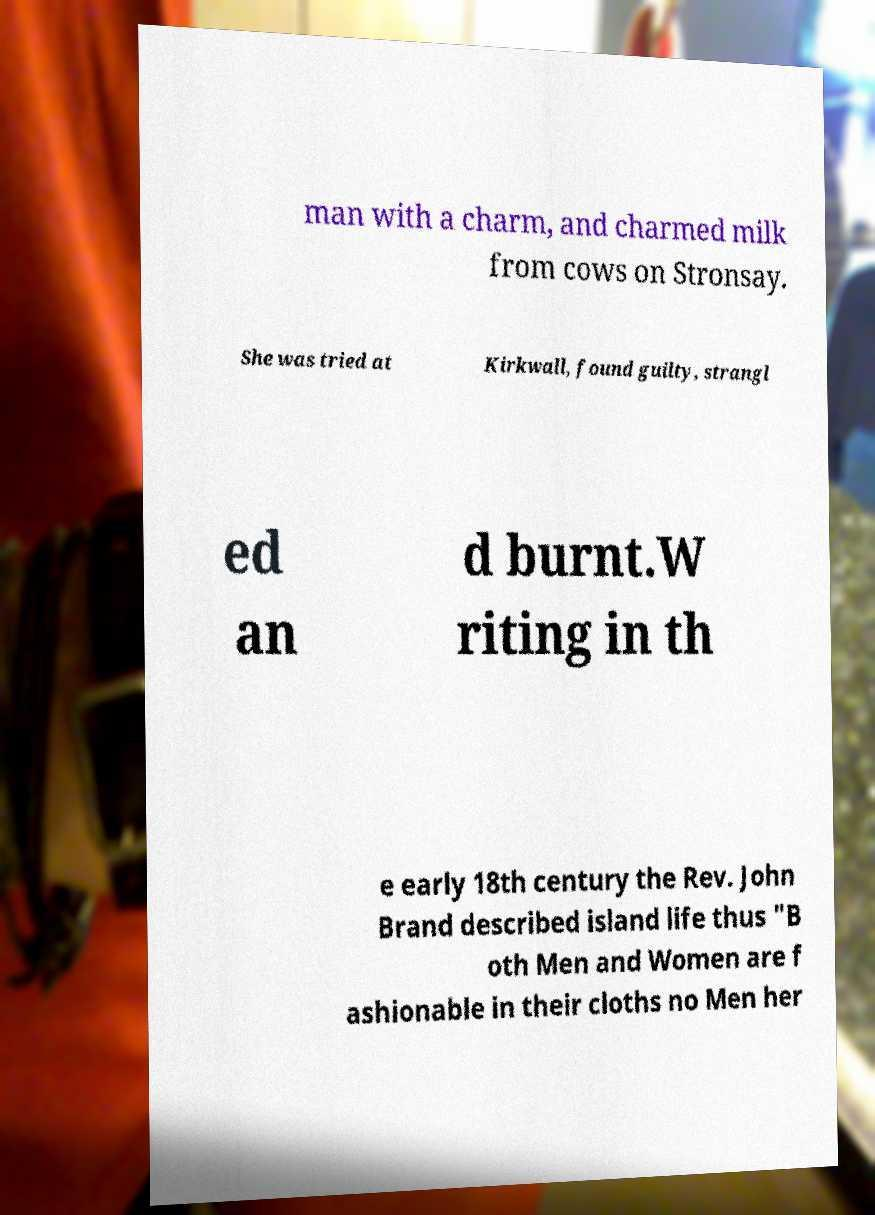Could you assist in decoding the text presented in this image and type it out clearly? man with a charm, and charmed milk from cows on Stronsay. She was tried at Kirkwall, found guilty, strangl ed an d burnt.W riting in th e early 18th century the Rev. John Brand described island life thus "B oth Men and Women are f ashionable in their cloths no Men her 